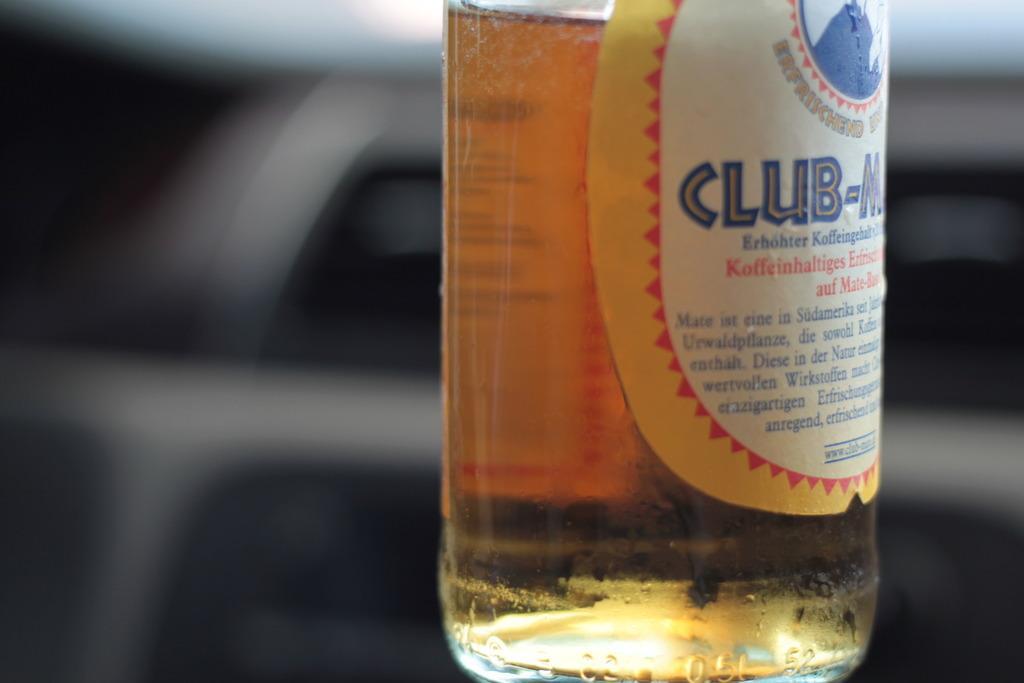Can you describe this image briefly? If you look into this image you can observe there is a bottle. Which consists of liquid and also there is a label on the bottle. Which has a name of Club-M and also you can observe the symbol here which is in blue color. 